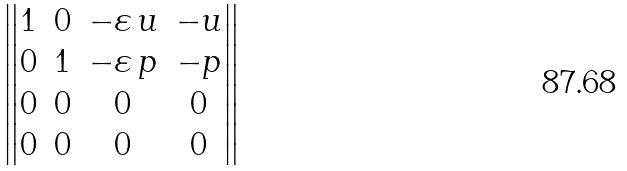Convert formula to latex. <formula><loc_0><loc_0><loc_500><loc_500>\begin{Vmatrix} 1 & 0 & - \varepsilon \, u & - u \\ 0 & 1 & - \varepsilon \, p & - p \\ 0 & 0 & 0 & 0 \\ 0 & 0 & 0 & 0 \end{Vmatrix}</formula> 